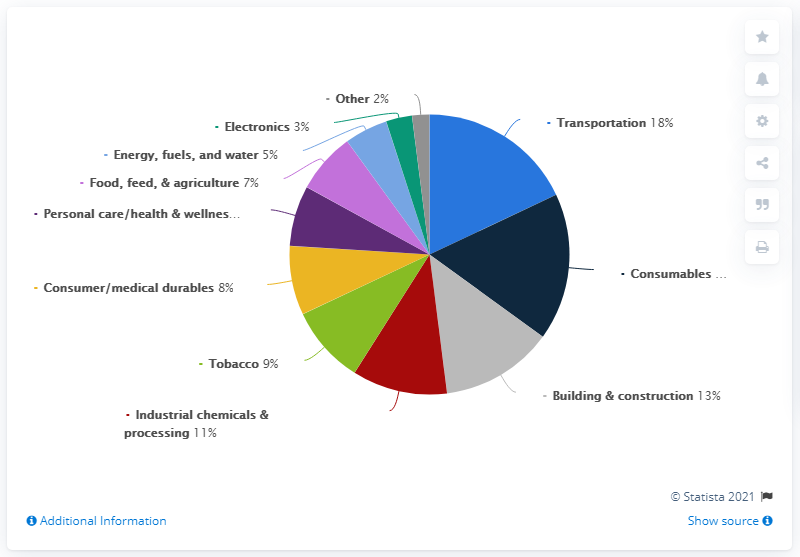List a handful of essential elements in this visual. The sum total of transportation and tobacco as part of Eastman Chemical Company's revenue as of 2020 was $27 million. In 2020, approximately 18% of Eastman Chemical Company's revenue was generated from the transportation industry. 